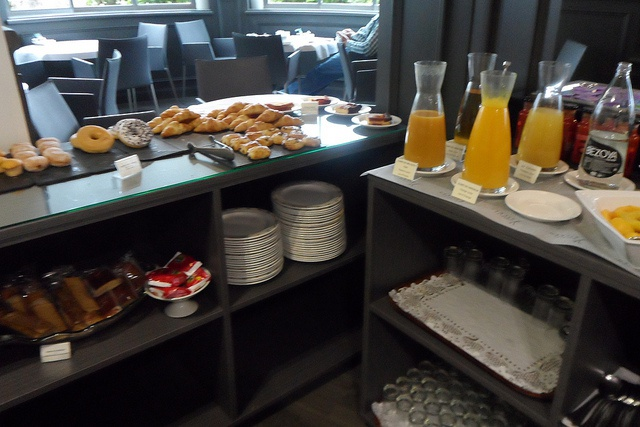Describe the objects in this image and their specific colors. I can see bottle in gray, black, and maroon tones, bottle in gray and orange tones, bottle in gray and olive tones, bottle in gray, olive, darkgray, and tan tones, and chair in gray, black, and blue tones in this image. 